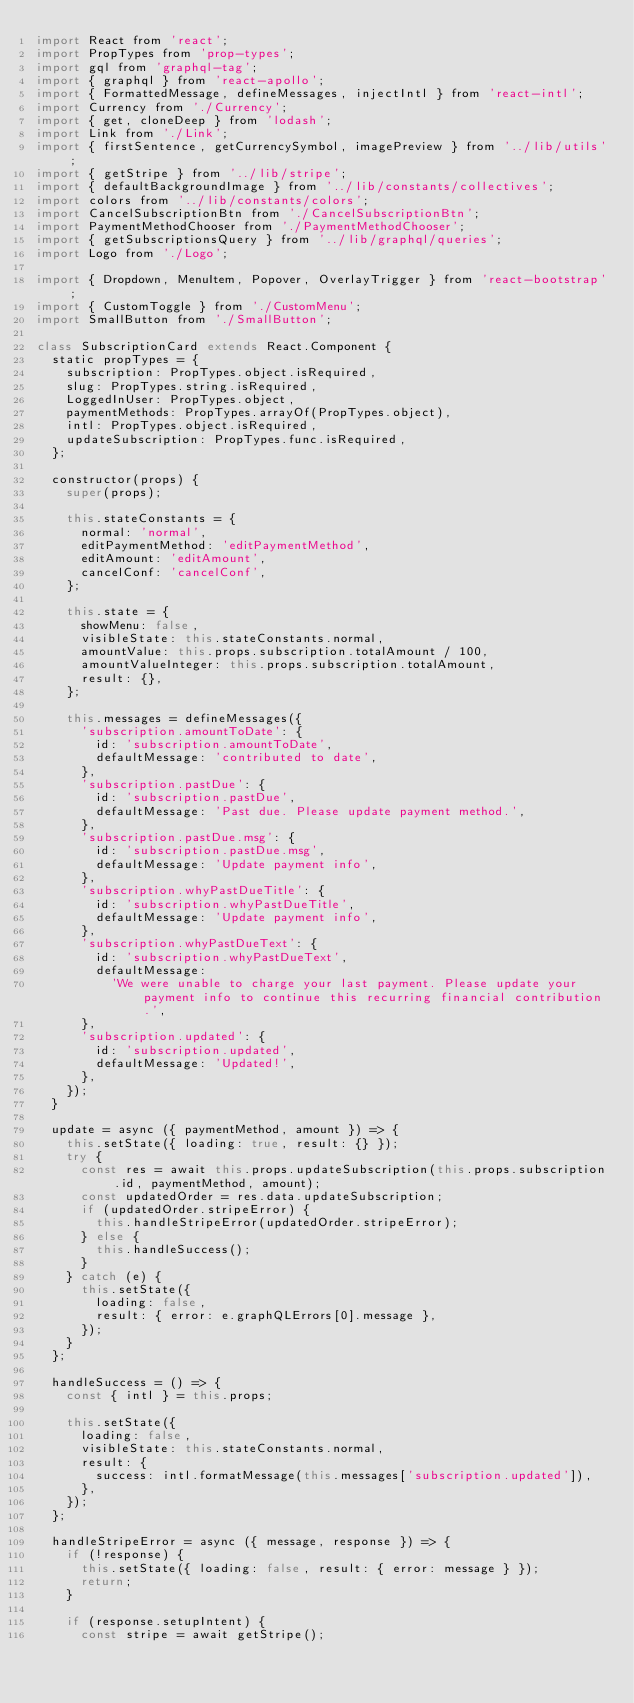<code> <loc_0><loc_0><loc_500><loc_500><_JavaScript_>import React from 'react';
import PropTypes from 'prop-types';
import gql from 'graphql-tag';
import { graphql } from 'react-apollo';
import { FormattedMessage, defineMessages, injectIntl } from 'react-intl';
import Currency from './Currency';
import { get, cloneDeep } from 'lodash';
import Link from './Link';
import { firstSentence, getCurrencySymbol, imagePreview } from '../lib/utils';
import { getStripe } from '../lib/stripe';
import { defaultBackgroundImage } from '../lib/constants/collectives';
import colors from '../lib/constants/colors';
import CancelSubscriptionBtn from './CancelSubscriptionBtn';
import PaymentMethodChooser from './PaymentMethodChooser';
import { getSubscriptionsQuery } from '../lib/graphql/queries';
import Logo from './Logo';

import { Dropdown, MenuItem, Popover, OverlayTrigger } from 'react-bootstrap';
import { CustomToggle } from './CustomMenu';
import SmallButton from './SmallButton';

class SubscriptionCard extends React.Component {
  static propTypes = {
    subscription: PropTypes.object.isRequired,
    slug: PropTypes.string.isRequired,
    LoggedInUser: PropTypes.object,
    paymentMethods: PropTypes.arrayOf(PropTypes.object),
    intl: PropTypes.object.isRequired,
    updateSubscription: PropTypes.func.isRequired,
  };

  constructor(props) {
    super(props);

    this.stateConstants = {
      normal: 'normal',
      editPaymentMethod: 'editPaymentMethod',
      editAmount: 'editAmount',
      cancelConf: 'cancelConf',
    };

    this.state = {
      showMenu: false,
      visibleState: this.stateConstants.normal,
      amountValue: this.props.subscription.totalAmount / 100,
      amountValueInteger: this.props.subscription.totalAmount,
      result: {},
    };

    this.messages = defineMessages({
      'subscription.amountToDate': {
        id: 'subscription.amountToDate',
        defaultMessage: 'contributed to date',
      },
      'subscription.pastDue': {
        id: 'subscription.pastDue',
        defaultMessage: 'Past due. Please update payment method.',
      },
      'subscription.pastDue.msg': {
        id: 'subscription.pastDue.msg',
        defaultMessage: 'Update payment info',
      },
      'subscription.whyPastDueTitle': {
        id: 'subscription.whyPastDueTitle',
        defaultMessage: 'Update payment info',
      },
      'subscription.whyPastDueText': {
        id: 'subscription.whyPastDueText',
        defaultMessage:
          'We were unable to charge your last payment. Please update your payment info to continue this recurring financial contribution.',
      },
      'subscription.updated': {
        id: 'subscription.updated',
        defaultMessage: 'Updated!',
      },
    });
  }

  update = async ({ paymentMethod, amount }) => {
    this.setState({ loading: true, result: {} });
    try {
      const res = await this.props.updateSubscription(this.props.subscription.id, paymentMethod, amount);
      const updatedOrder = res.data.updateSubscription;
      if (updatedOrder.stripeError) {
        this.handleStripeError(updatedOrder.stripeError);
      } else {
        this.handleSuccess();
      }
    } catch (e) {
      this.setState({
        loading: false,
        result: { error: e.graphQLErrors[0].message },
      });
    }
  };

  handleSuccess = () => {
    const { intl } = this.props;

    this.setState({
      loading: false,
      visibleState: this.stateConstants.normal,
      result: {
        success: intl.formatMessage(this.messages['subscription.updated']),
      },
    });
  };

  handleStripeError = async ({ message, response }) => {
    if (!response) {
      this.setState({ loading: false, result: { error: message } });
      return;
    }

    if (response.setupIntent) {
      const stripe = await getStripe();</code> 